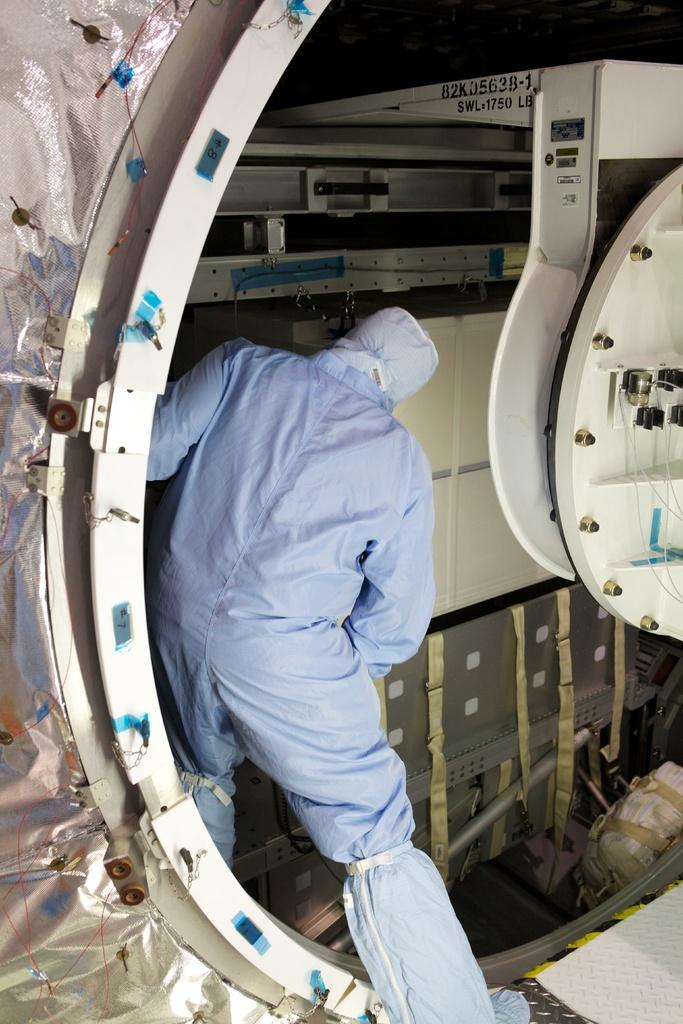What type of figure can be seen in the image? There is a human in the image. What other object is present in the image? There is a machine in a container in the image. What type of badge is the human wearing in the image? There is no badge visible on the human in the image. How is the organization represented in the image? The image does not depict any organization; it only shows a human and a machine in a container. 